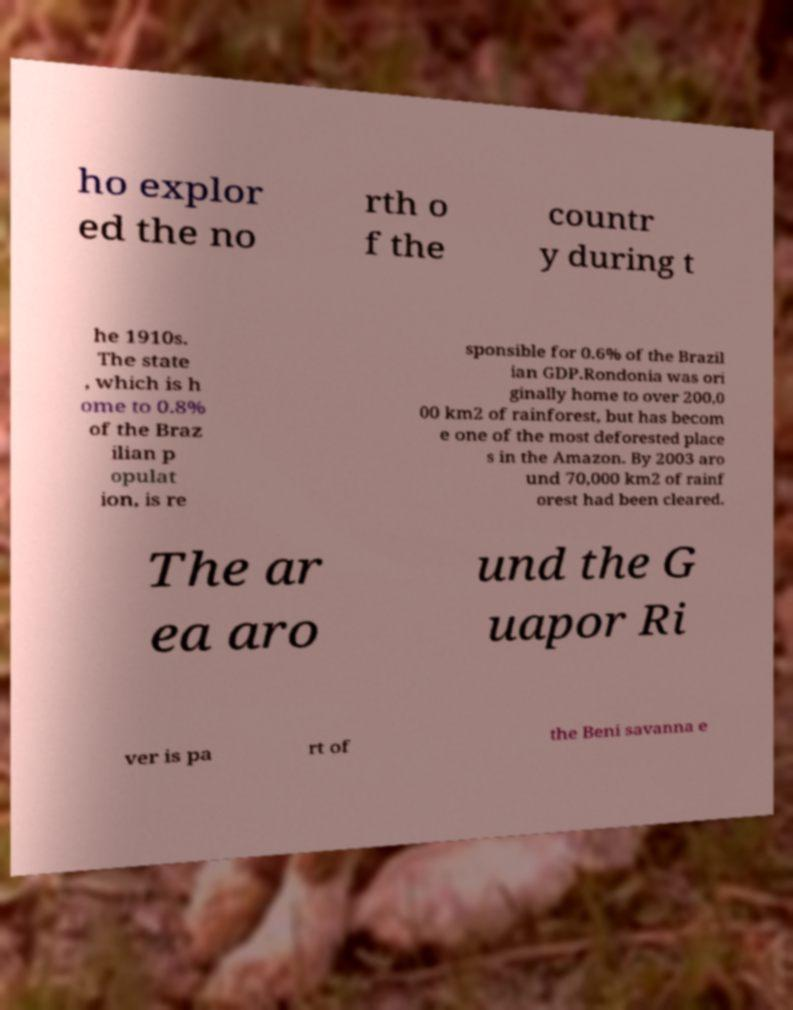Please read and relay the text visible in this image. What does it say? ho explor ed the no rth o f the countr y during t he 1910s. The state , which is h ome to 0.8% of the Braz ilian p opulat ion, is re sponsible for 0.6% of the Brazil ian GDP.Rondonia was ori ginally home to over 200,0 00 km2 of rainforest, but has becom e one of the most deforested place s in the Amazon. By 2003 aro und 70,000 km2 of rainf orest had been cleared. The ar ea aro und the G uapor Ri ver is pa rt of the Beni savanna e 